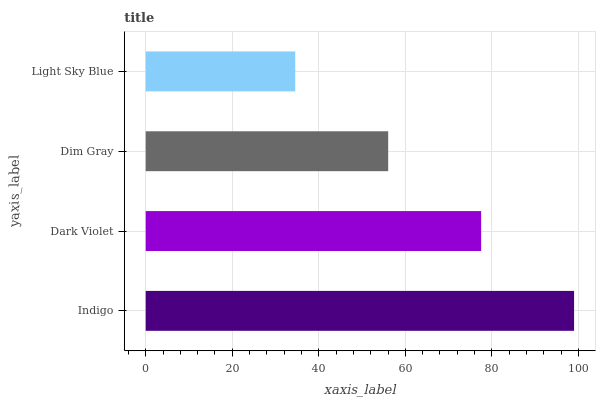Is Light Sky Blue the minimum?
Answer yes or no. Yes. Is Indigo the maximum?
Answer yes or no. Yes. Is Dark Violet the minimum?
Answer yes or no. No. Is Dark Violet the maximum?
Answer yes or no. No. Is Indigo greater than Dark Violet?
Answer yes or no. Yes. Is Dark Violet less than Indigo?
Answer yes or no. Yes. Is Dark Violet greater than Indigo?
Answer yes or no. No. Is Indigo less than Dark Violet?
Answer yes or no. No. Is Dark Violet the high median?
Answer yes or no. Yes. Is Dim Gray the low median?
Answer yes or no. Yes. Is Indigo the high median?
Answer yes or no. No. Is Indigo the low median?
Answer yes or no. No. 